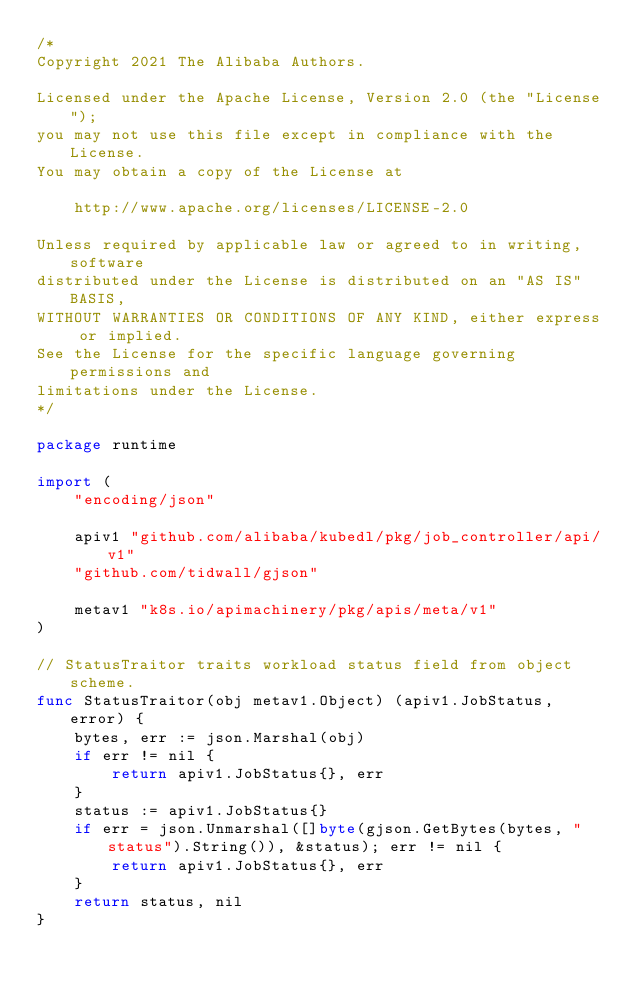Convert code to text. <code><loc_0><loc_0><loc_500><loc_500><_Go_>/*
Copyright 2021 The Alibaba Authors.

Licensed under the Apache License, Version 2.0 (the "License");
you may not use this file except in compliance with the License.
You may obtain a copy of the License at

    http://www.apache.org/licenses/LICENSE-2.0

Unless required by applicable law or agreed to in writing, software
distributed under the License is distributed on an "AS IS" BASIS,
WITHOUT WARRANTIES OR CONDITIONS OF ANY KIND, either express or implied.
See the License for the specific language governing permissions and
limitations under the License.
*/

package runtime

import (
	"encoding/json"

	apiv1 "github.com/alibaba/kubedl/pkg/job_controller/api/v1"
	"github.com/tidwall/gjson"

	metav1 "k8s.io/apimachinery/pkg/apis/meta/v1"
)

// StatusTraitor traits workload status field from object scheme.
func StatusTraitor(obj metav1.Object) (apiv1.JobStatus, error) {
	bytes, err := json.Marshal(obj)
	if err != nil {
		return apiv1.JobStatus{}, err
	}
	status := apiv1.JobStatus{}
	if err = json.Unmarshal([]byte(gjson.GetBytes(bytes, "status").String()), &status); err != nil {
		return apiv1.JobStatus{}, err
	}
	return status, nil
}
</code> 